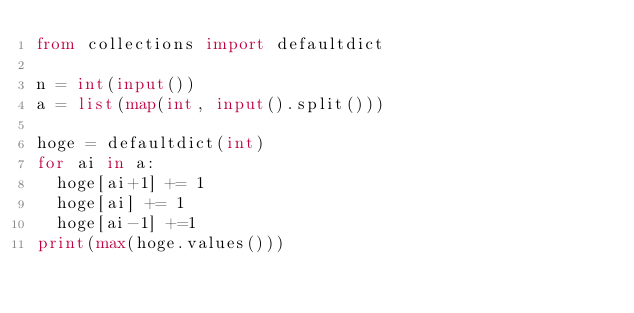Convert code to text. <code><loc_0><loc_0><loc_500><loc_500><_Python_>from collections import defaultdict

n = int(input())
a = list(map(int, input().split()))

hoge = defaultdict(int)
for ai in a:
  hoge[ai+1] += 1
  hoge[ai] += 1
  hoge[ai-1] +=1
print(max(hoge.values()))
</code> 